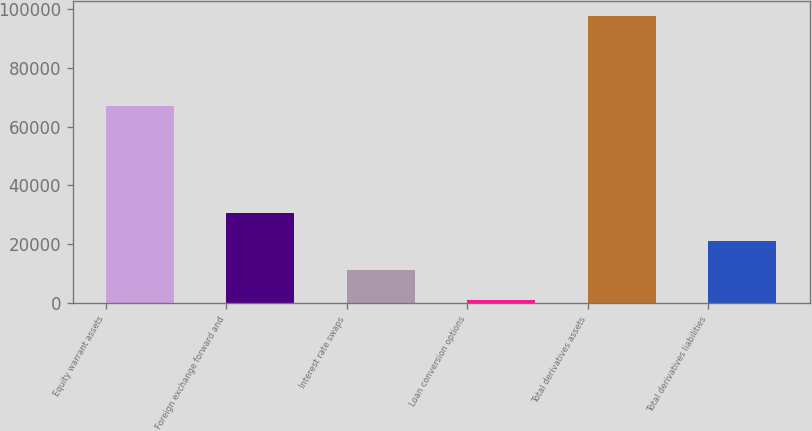Convert chart. <chart><loc_0><loc_0><loc_500><loc_500><bar_chart><fcel>Equity warrant assets<fcel>Foreign exchange forward and<fcel>Interest rate swaps<fcel>Loan conversion options<fcel>Total derivatives assets<fcel>Total derivatives liabilities<nl><fcel>66953<fcel>30795<fcel>11441<fcel>923<fcel>97693<fcel>21118<nl></chart> 